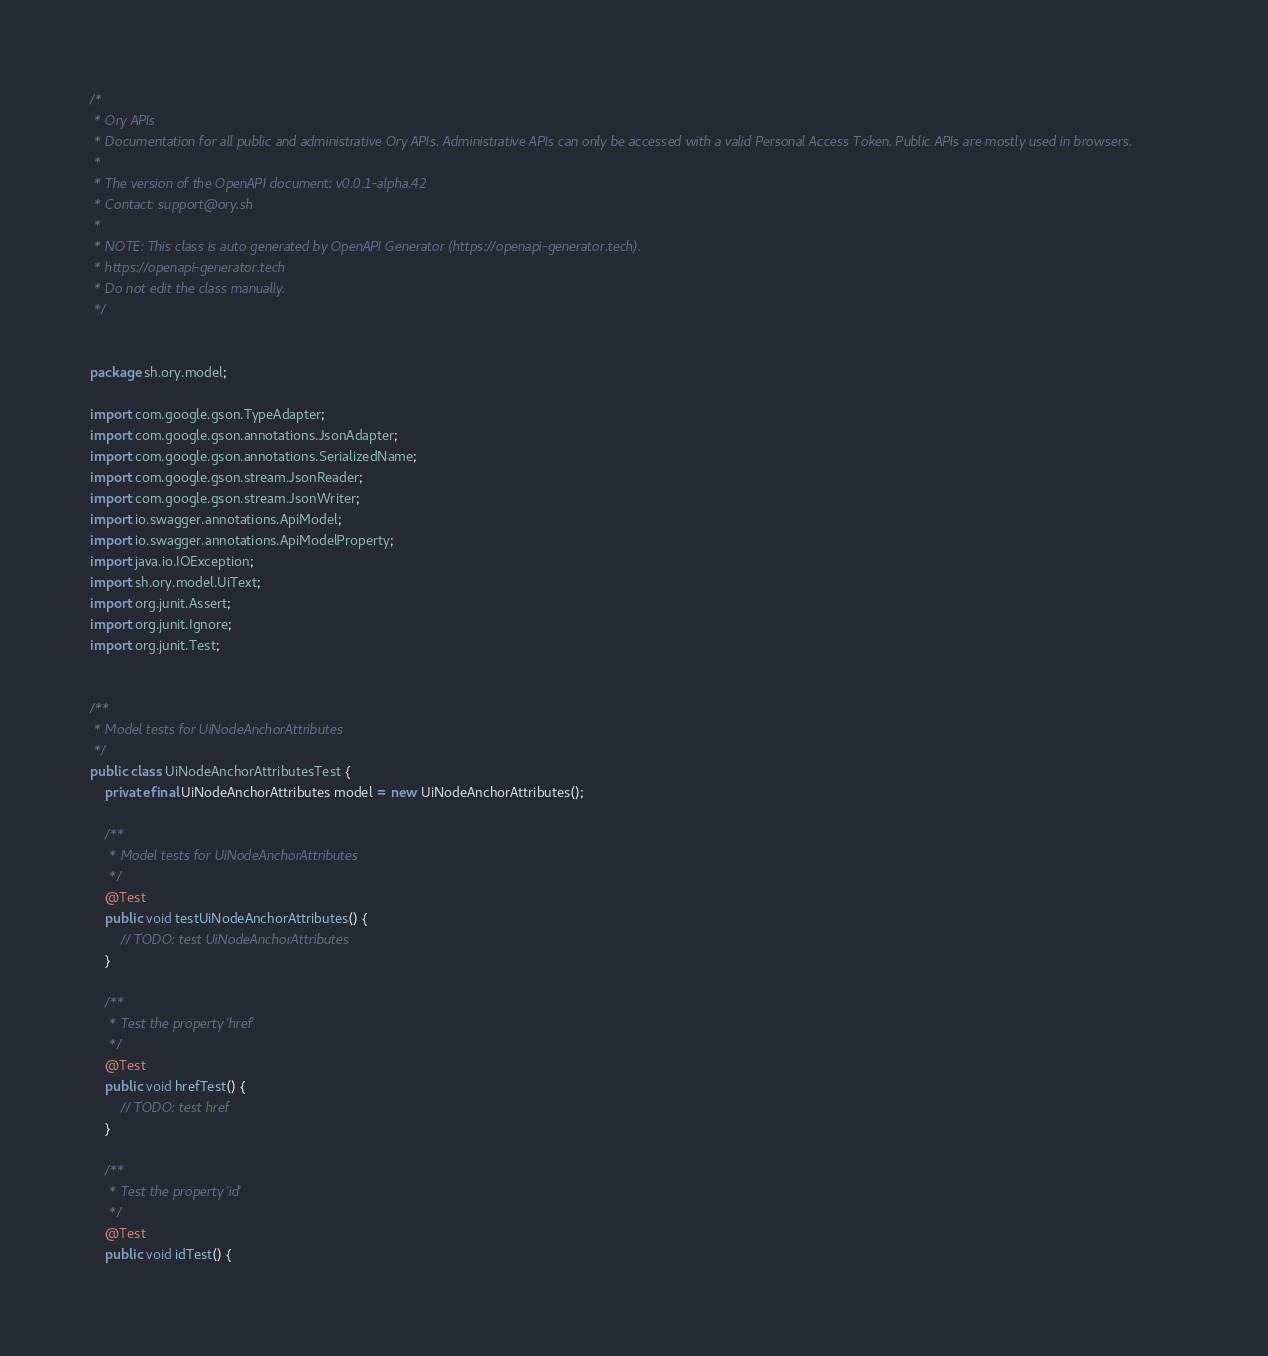<code> <loc_0><loc_0><loc_500><loc_500><_Java_>/*
 * Ory APIs
 * Documentation for all public and administrative Ory APIs. Administrative APIs can only be accessed with a valid Personal Access Token. Public APIs are mostly used in browsers. 
 *
 * The version of the OpenAPI document: v0.0.1-alpha.42
 * Contact: support@ory.sh
 *
 * NOTE: This class is auto generated by OpenAPI Generator (https://openapi-generator.tech).
 * https://openapi-generator.tech
 * Do not edit the class manually.
 */


package sh.ory.model;

import com.google.gson.TypeAdapter;
import com.google.gson.annotations.JsonAdapter;
import com.google.gson.annotations.SerializedName;
import com.google.gson.stream.JsonReader;
import com.google.gson.stream.JsonWriter;
import io.swagger.annotations.ApiModel;
import io.swagger.annotations.ApiModelProperty;
import java.io.IOException;
import sh.ory.model.UiText;
import org.junit.Assert;
import org.junit.Ignore;
import org.junit.Test;


/**
 * Model tests for UiNodeAnchorAttributes
 */
public class UiNodeAnchorAttributesTest {
    private final UiNodeAnchorAttributes model = new UiNodeAnchorAttributes();

    /**
     * Model tests for UiNodeAnchorAttributes
     */
    @Test
    public void testUiNodeAnchorAttributes() {
        // TODO: test UiNodeAnchorAttributes
    }

    /**
     * Test the property 'href'
     */
    @Test
    public void hrefTest() {
        // TODO: test href
    }

    /**
     * Test the property 'id'
     */
    @Test
    public void idTest() {</code> 